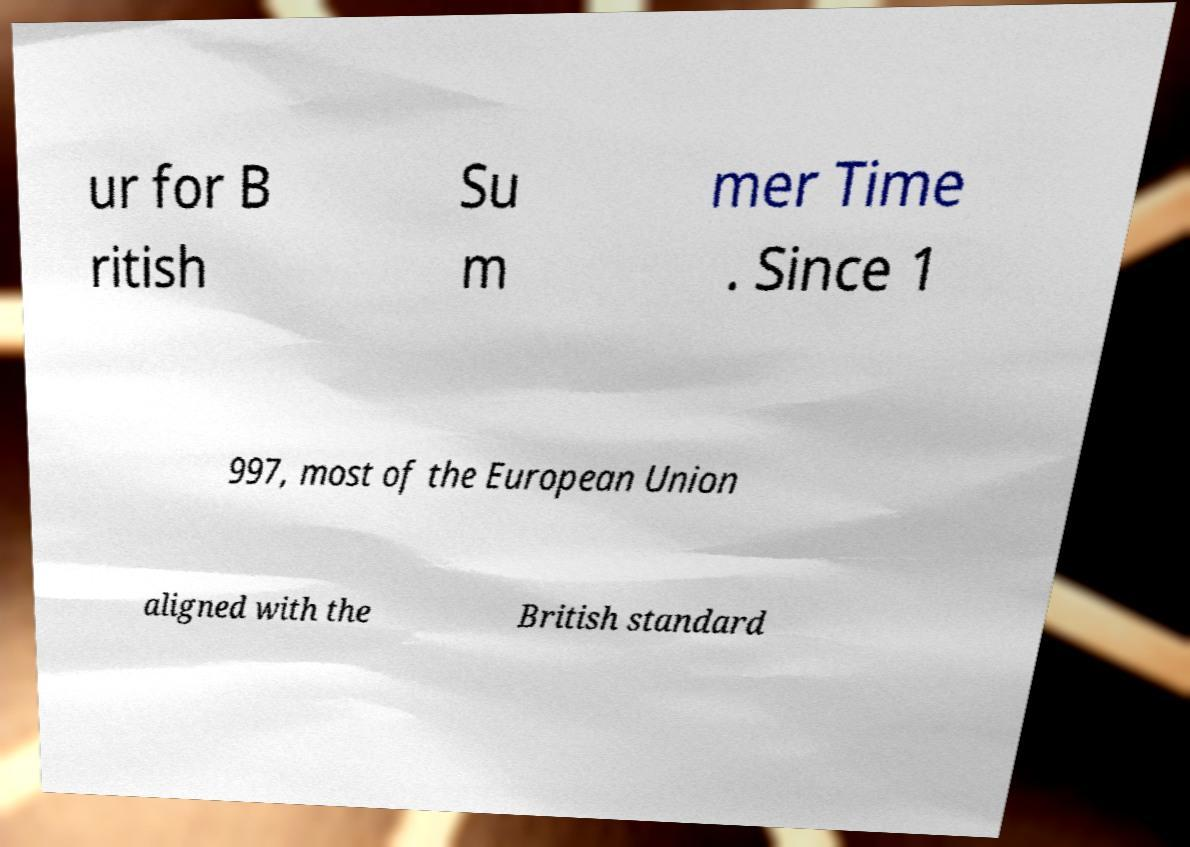What messages or text are displayed in this image? I need them in a readable, typed format. ur for B ritish Su m mer Time . Since 1 997, most of the European Union aligned with the British standard 